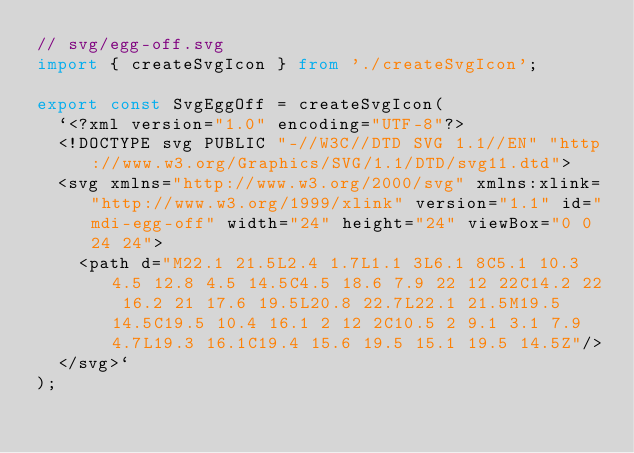Convert code to text. <code><loc_0><loc_0><loc_500><loc_500><_TypeScript_>// svg/egg-off.svg
import { createSvgIcon } from './createSvgIcon';

export const SvgEggOff = createSvgIcon(
  `<?xml version="1.0" encoding="UTF-8"?>
  <!DOCTYPE svg PUBLIC "-//W3C//DTD SVG 1.1//EN" "http://www.w3.org/Graphics/SVG/1.1/DTD/svg11.dtd">
  <svg xmlns="http://www.w3.org/2000/svg" xmlns:xlink="http://www.w3.org/1999/xlink" version="1.1" id="mdi-egg-off" width="24" height="24" viewBox="0 0 24 24">
    <path d="M22.1 21.5L2.4 1.7L1.1 3L6.1 8C5.1 10.3 4.5 12.8 4.5 14.5C4.5 18.6 7.9 22 12 22C14.2 22 16.2 21 17.6 19.5L20.8 22.7L22.1 21.5M19.5 14.5C19.5 10.4 16.1 2 12 2C10.5 2 9.1 3.1 7.9 4.7L19.3 16.1C19.4 15.6 19.5 15.1 19.5 14.5Z"/>
  </svg>`
);

</code> 